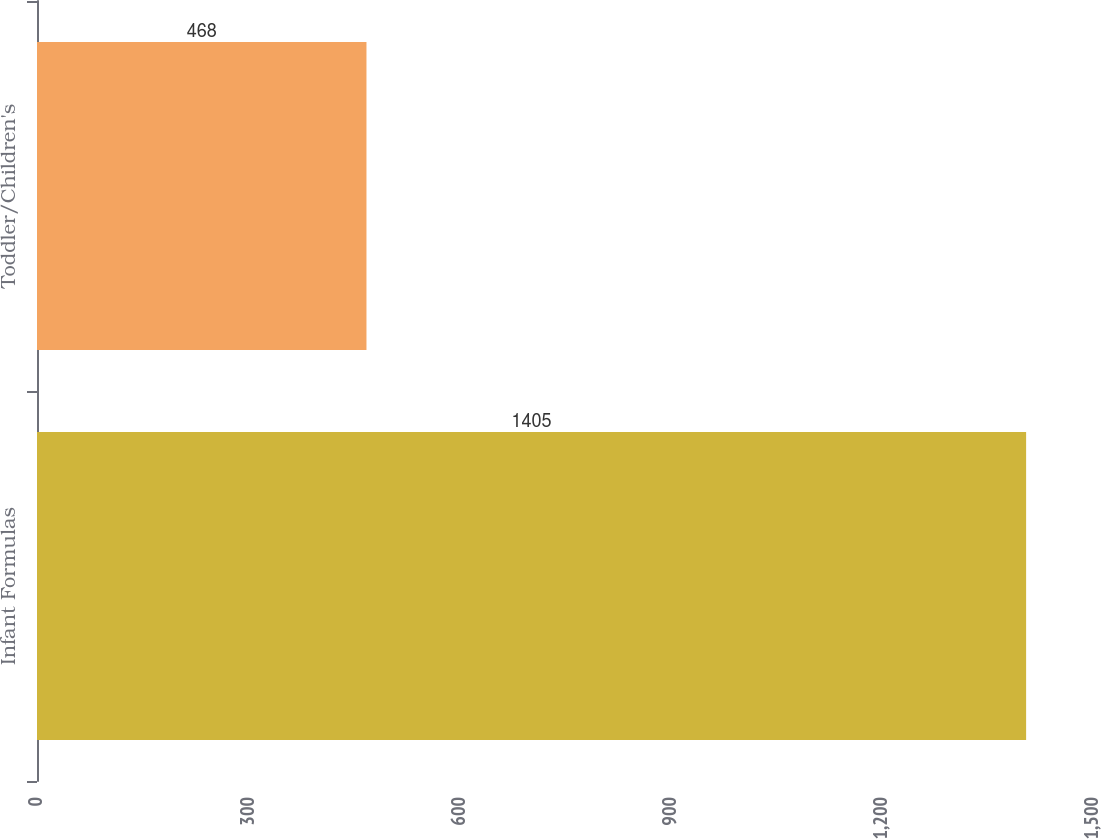Convert chart to OTSL. <chart><loc_0><loc_0><loc_500><loc_500><bar_chart><fcel>Infant Formulas<fcel>Toddler/Children's<nl><fcel>1405<fcel>468<nl></chart> 